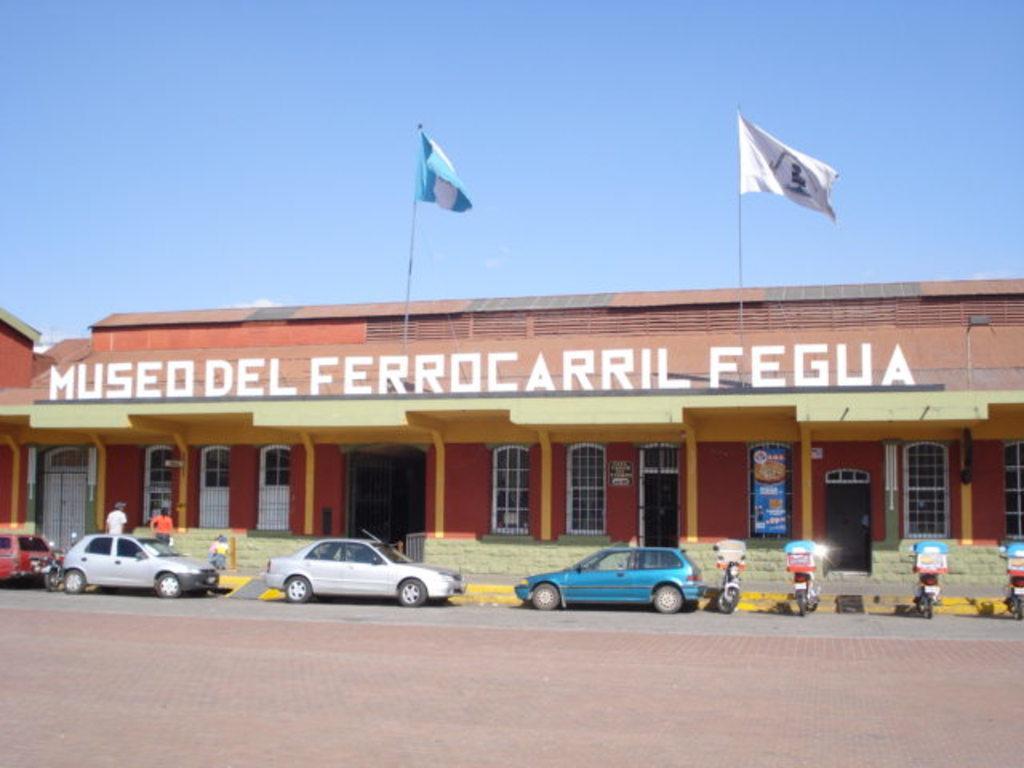In one or two sentences, can you explain what this image depicts? In this image we can see the road. And we can see some vehicles. And we can see some people. And we can see the doors, windows. And we can see two flags. And we can see the sky at the top. 